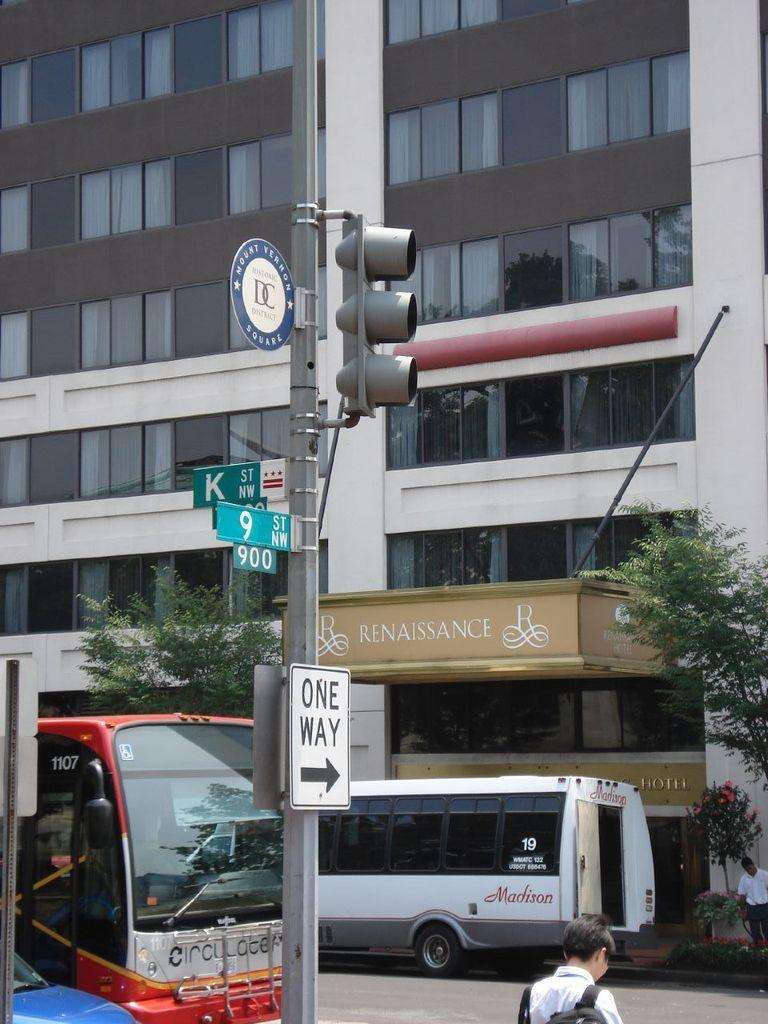What type of structure is visible in the image? There is a building in the image. What is located in front of the building? There are trees in front of the building. What mode of transportation can be seen on the road? There are two buses on the road. Can you identify any people in the image? Yes, there is a person in the image. What traffic control device is present in the image? There is a traffic light in the image. Are there any signs visible in the image? Yes, there are sign boards in the image. What type of leaf is being used to heal the wound on the person's arm in the image? There is no leaf or wound present in the image; it only features a building, trees, buses, a person, a traffic light, and sign boards. 